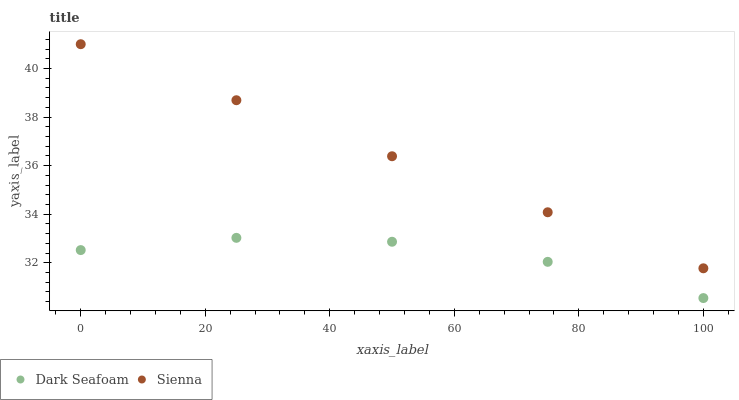Does Dark Seafoam have the minimum area under the curve?
Answer yes or no. Yes. Does Sienna have the maximum area under the curve?
Answer yes or no. Yes. Does Dark Seafoam have the maximum area under the curve?
Answer yes or no. No. Is Sienna the smoothest?
Answer yes or no. Yes. Is Dark Seafoam the roughest?
Answer yes or no. Yes. Is Dark Seafoam the smoothest?
Answer yes or no. No. Does Dark Seafoam have the lowest value?
Answer yes or no. Yes. Does Sienna have the highest value?
Answer yes or no. Yes. Does Dark Seafoam have the highest value?
Answer yes or no. No. Is Dark Seafoam less than Sienna?
Answer yes or no. Yes. Is Sienna greater than Dark Seafoam?
Answer yes or no. Yes. Does Dark Seafoam intersect Sienna?
Answer yes or no. No. 